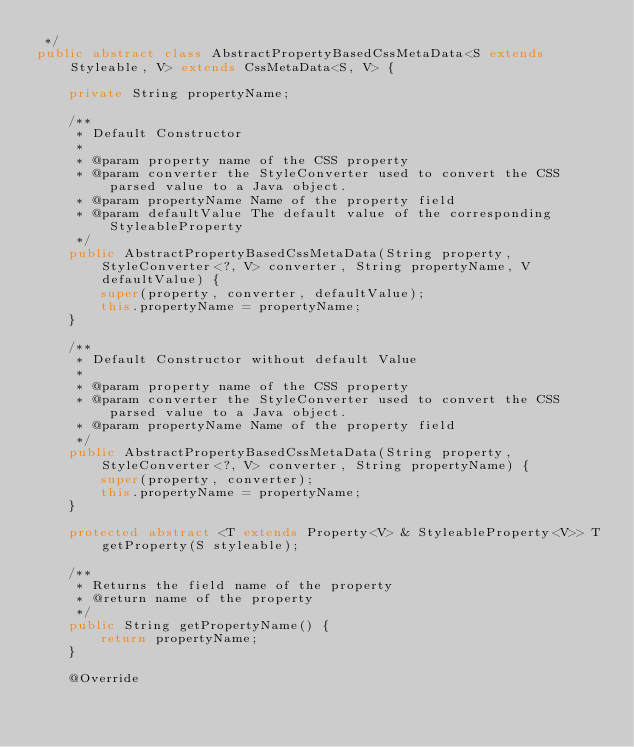Convert code to text. <code><loc_0><loc_0><loc_500><loc_500><_Java_> */
public abstract class AbstractPropertyBasedCssMetaData<S extends Styleable, V> extends CssMetaData<S, V> {

    private String propertyName;

    /**
     * Default Constructor
     *
     * @param property name of the CSS property
     * @param converter the StyleConverter used to convert the CSS parsed value to a Java object.
     * @param propertyName Name of the property field
     * @param defaultValue The default value of the corresponding StyleableProperty
     */
    public AbstractPropertyBasedCssMetaData(String property, StyleConverter<?, V> converter, String propertyName, V defaultValue) {
        super(property, converter, defaultValue);
        this.propertyName = propertyName;
    }

    /**
     * Default Constructor without default Value
     *
     * @param property name of the CSS property
     * @param converter the StyleConverter used to convert the CSS parsed value to a Java object.
     * @param propertyName Name of the property field
     */
    public AbstractPropertyBasedCssMetaData(String property, StyleConverter<?, V> converter, String propertyName) {
        super(property, converter);
        this.propertyName = propertyName;
    }
    
    protected abstract <T extends Property<V> & StyleableProperty<V>> T getProperty(S styleable);

    /**
     * Returns the field name of the property
     * @return name of the property
     */
    public String getPropertyName() {
        return propertyName;
    }

    @Override</code> 